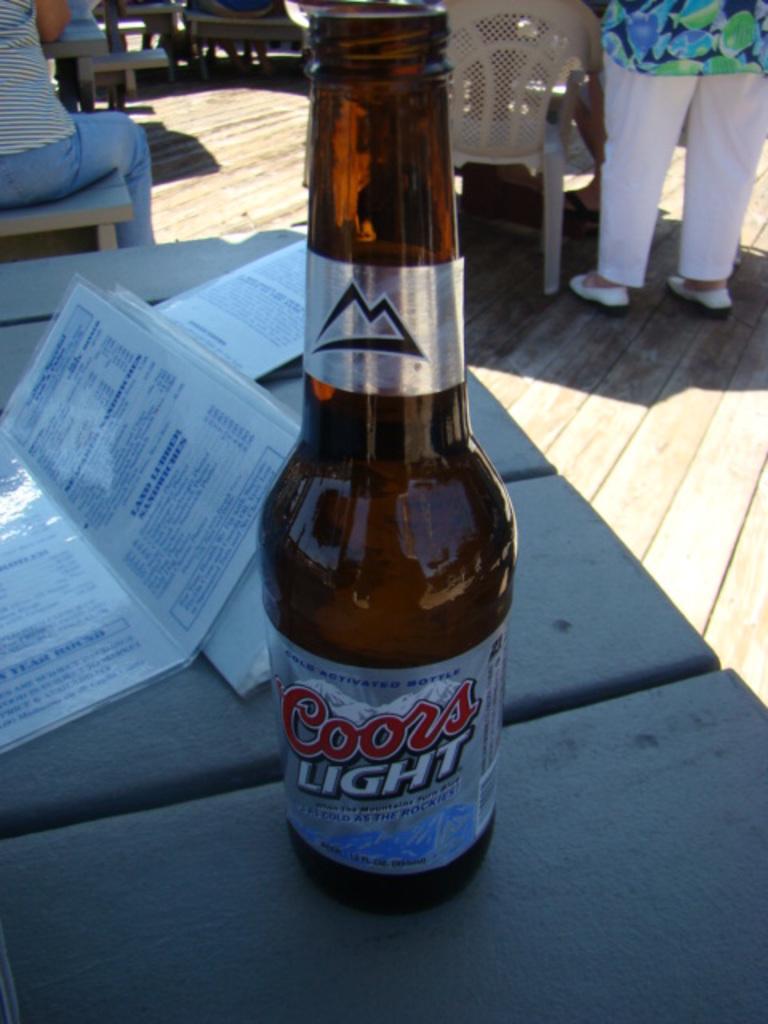Could you give a brief overview of what you see in this image? In the photo there is a table and there are some menu cards on the table beside them there is a bottle, to the right side a person is standing ,there is a lot of sunlight. 